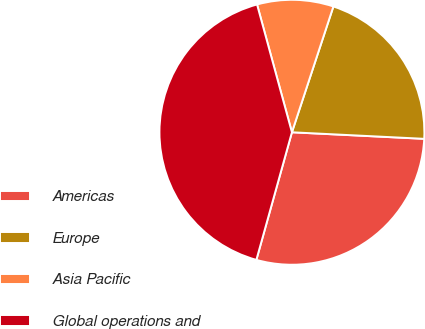<chart> <loc_0><loc_0><loc_500><loc_500><pie_chart><fcel>Americas<fcel>Europe<fcel>Asia Pacific<fcel>Global operations and<nl><fcel>28.54%<fcel>20.72%<fcel>9.31%<fcel>41.44%<nl></chart> 